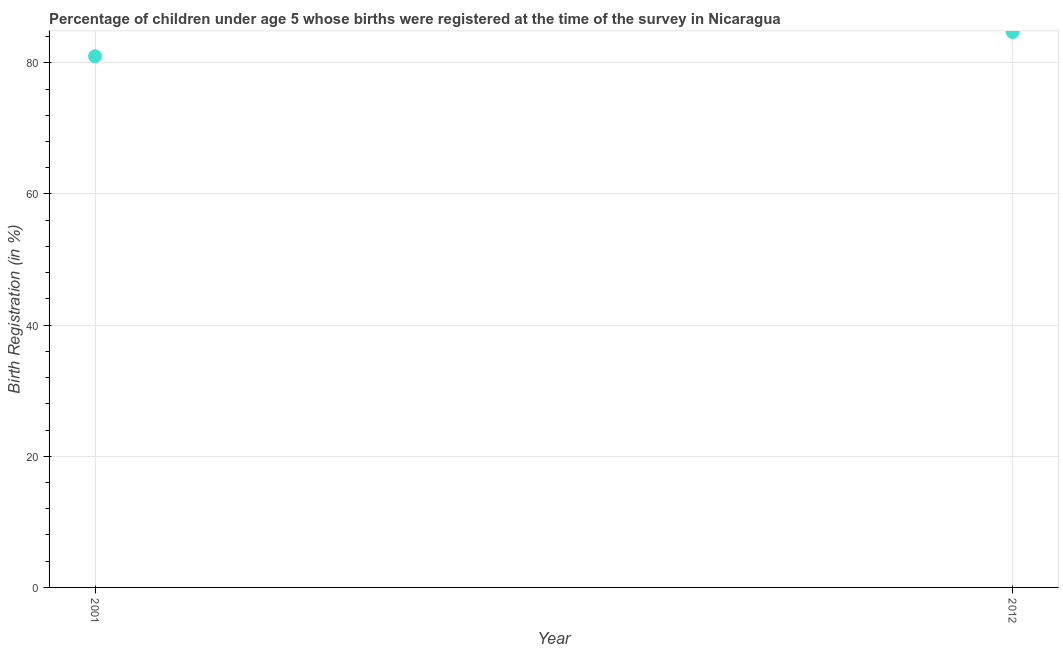Across all years, what is the maximum birth registration?
Provide a short and direct response. 84.7. In which year was the birth registration maximum?
Your answer should be very brief. 2012. What is the sum of the birth registration?
Give a very brief answer. 165.7. What is the difference between the birth registration in 2001 and 2012?
Your answer should be compact. -3.7. What is the average birth registration per year?
Give a very brief answer. 82.85. What is the median birth registration?
Your answer should be compact. 82.85. In how many years, is the birth registration greater than 20 %?
Provide a succinct answer. 2. Do a majority of the years between 2001 and 2012 (inclusive) have birth registration greater than 36 %?
Provide a succinct answer. Yes. What is the ratio of the birth registration in 2001 to that in 2012?
Provide a short and direct response. 0.96. Is the birth registration in 2001 less than that in 2012?
Provide a short and direct response. Yes. In how many years, is the birth registration greater than the average birth registration taken over all years?
Your answer should be compact. 1. What is the difference between two consecutive major ticks on the Y-axis?
Offer a very short reply. 20. Does the graph contain grids?
Ensure brevity in your answer.  Yes. What is the title of the graph?
Keep it short and to the point. Percentage of children under age 5 whose births were registered at the time of the survey in Nicaragua. What is the label or title of the Y-axis?
Ensure brevity in your answer.  Birth Registration (in %). What is the Birth Registration (in %) in 2001?
Your answer should be compact. 81. What is the Birth Registration (in %) in 2012?
Provide a succinct answer. 84.7. What is the ratio of the Birth Registration (in %) in 2001 to that in 2012?
Make the answer very short. 0.96. 